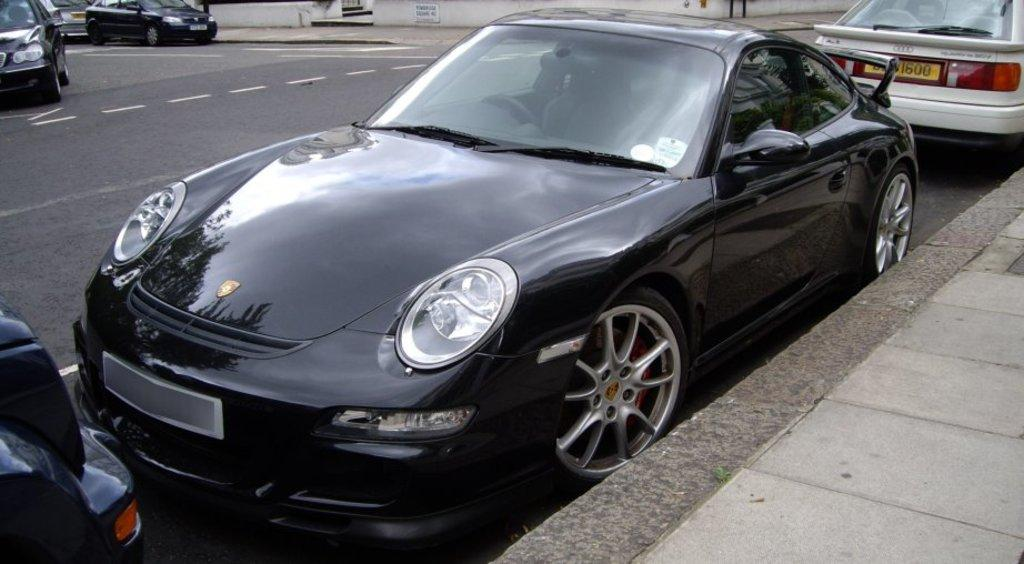What is happening in the center of the image? There are vehicles on the road in the image. Where are the vehicles located in relation to the image? The vehicles are in the center of the image. What can be seen on the right side of the image? There is a platform on the right side of the image. What is visible in the background of the image? There is a wall and other objects visible in the background of the image. What type of authority is present at the protest in the image? There is no protest or authority present in the image; it features vehicles on the road and a platform on the right side. 